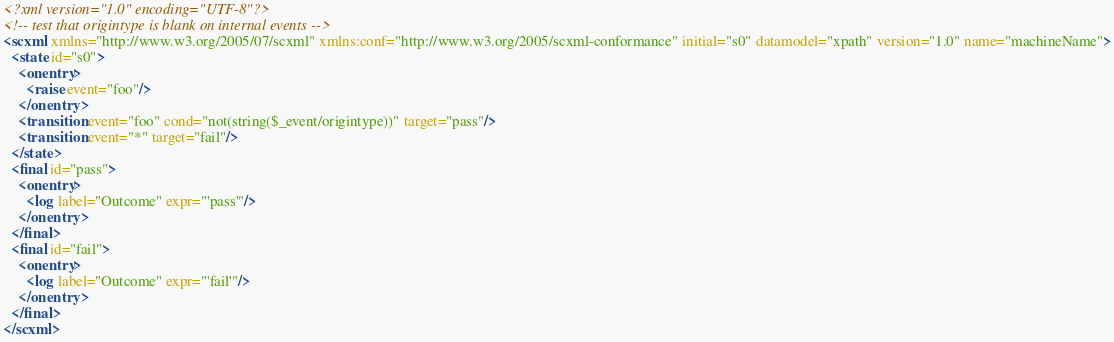Convert code to text. <code><loc_0><loc_0><loc_500><loc_500><_XML_><?xml version="1.0" encoding="UTF-8"?>
<!-- test that origintype is blank on internal events -->
<scxml xmlns="http://www.w3.org/2005/07/scxml" xmlns:conf="http://www.w3.org/2005/scxml-conformance" initial="s0" datamodel="xpath" version="1.0" name="machineName">
  <state id="s0">
    <onentry>
      <raise event="foo"/>
    </onentry>
    <transition event="foo" cond="not(string($_event/origintype))" target="pass"/>
    <transition event="*" target="fail"/>
  </state>
  <final id="pass">
    <onentry>
      <log label="Outcome" expr="'pass'"/>
    </onentry>
  </final>
  <final id="fail">
    <onentry>
      <log label="Outcome" expr="'fail'"/>
    </onentry>
  </final>
</scxml>
</code> 